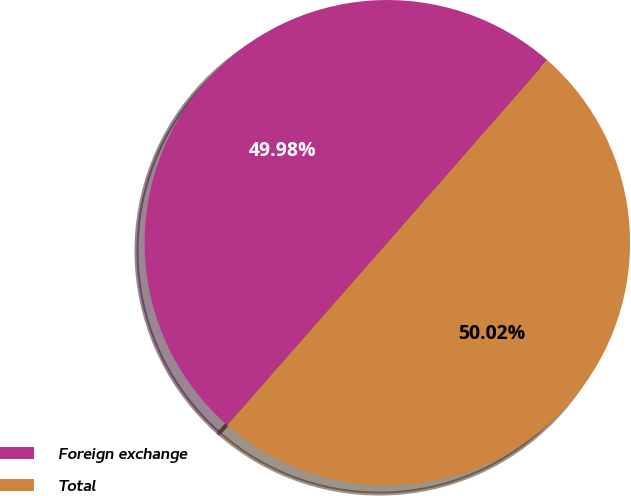Convert chart. <chart><loc_0><loc_0><loc_500><loc_500><pie_chart><fcel>Foreign exchange<fcel>Total<nl><fcel>49.98%<fcel>50.02%<nl></chart> 